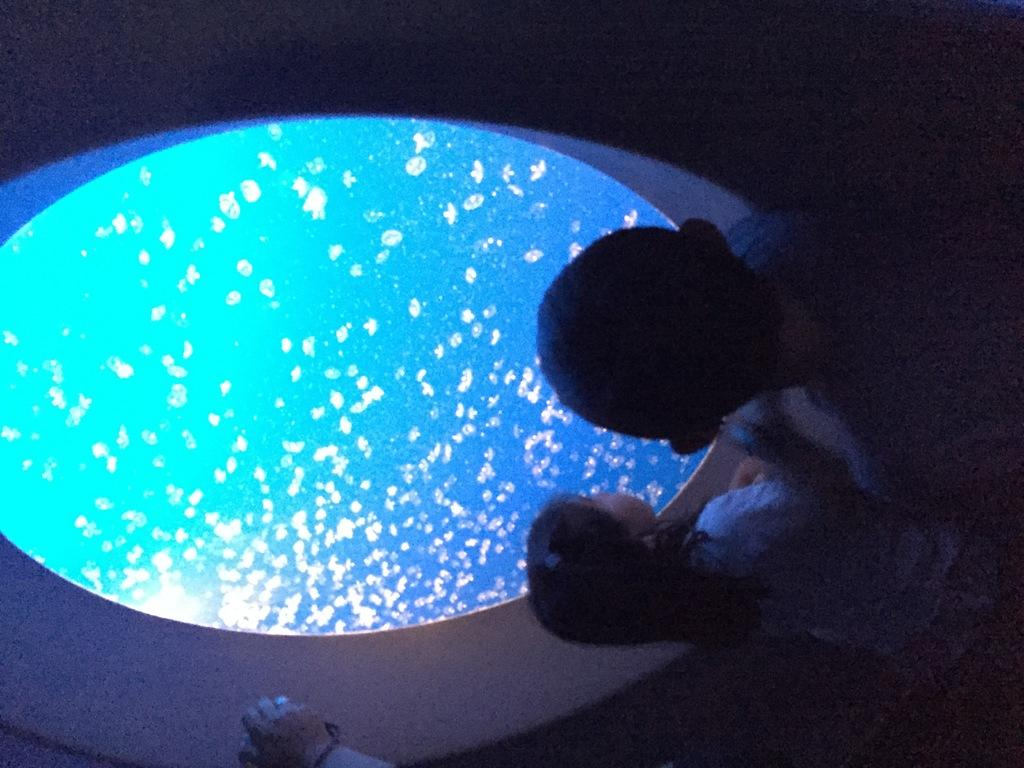Who or what is present in the image? There are people in the image. What can be observed about the background of the image? The background of the image is dark. What type of insect can be seen crawling on the person's mind in the image? There is no insect or reference to a person's mind present in the image. 